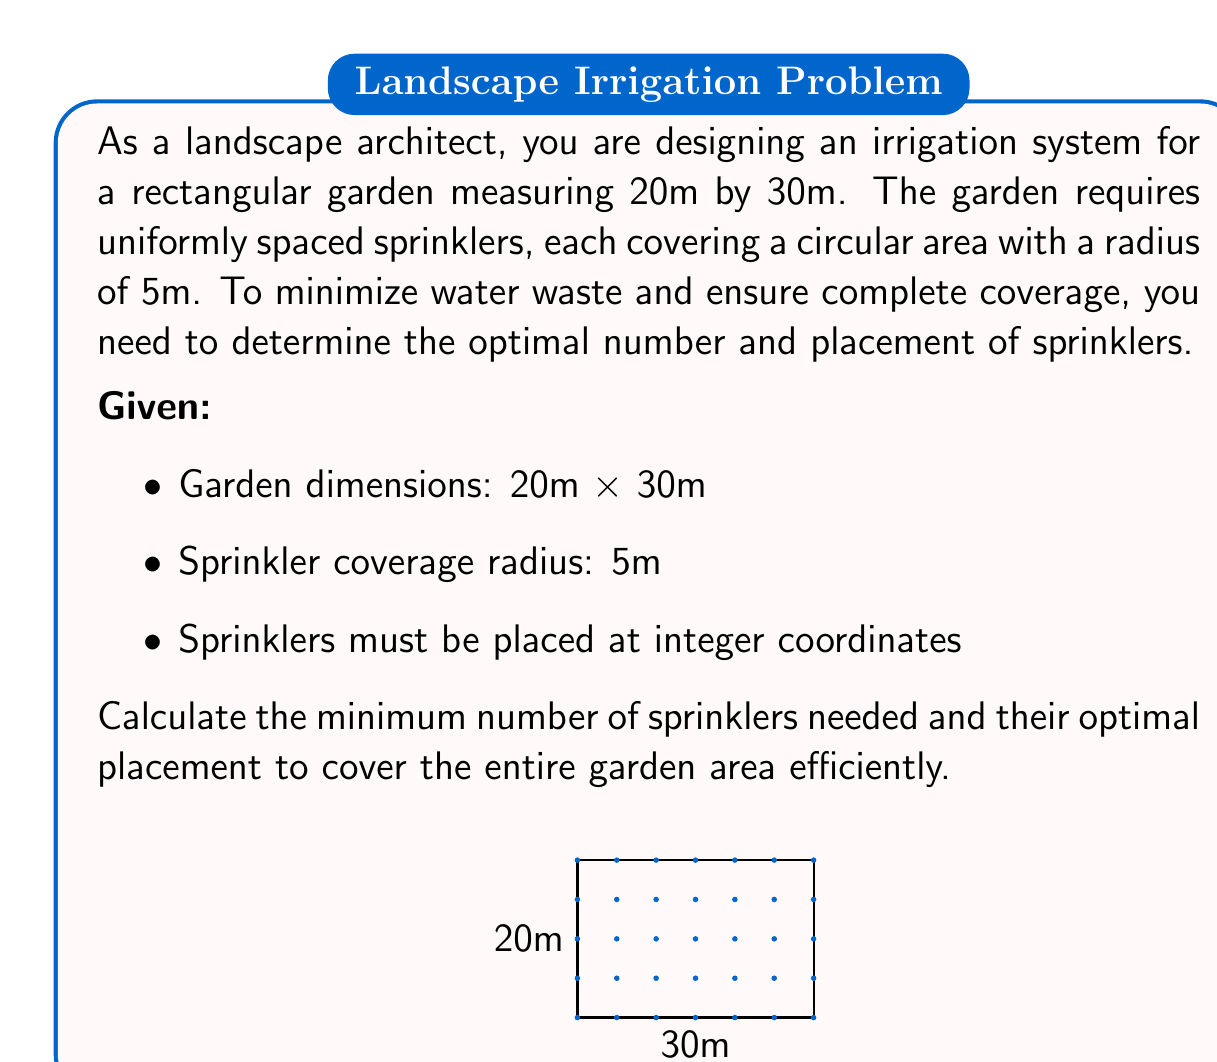Give your solution to this math problem. Let's approach this problem step-by-step:

1) First, we need to determine the optimal spacing between sprinklers. Since each sprinkler covers a radius of 5m, placing them 10m apart (2 × radius) would ensure complete coverage with minimal overlap.

2) For the 30m length:
   $\text{Number of sprinklers along length} = \left\lceil\frac{30}{10}\right\rceil = 3$

3) For the 20m width:
   $\text{Number of sprinklers along width} = \left\lceil\frac{20}{10}\right\rceil = 2$

4) Total number of sprinklers:
   $\text{Total sprinklers} = 3 \times 2 = 6$

5) To determine the optimal placement, we need to ensure even coverage:
   - Along the 30m length: place sprinklers at 5m, 15m, and 25m
   - Along the 20m width: place sprinklers at 5m and 15m

6) The coordinates for the sprinklers will be:
   (5,5), (15,5), (25,5), (5,15), (15,15), (25,15)

This arrangement ensures complete coverage of the garden with minimal overlap and water waste.
Answer: 6 sprinklers at coordinates: (5,5), (15,5), (25,5), (5,15), (15,15), (25,15) 